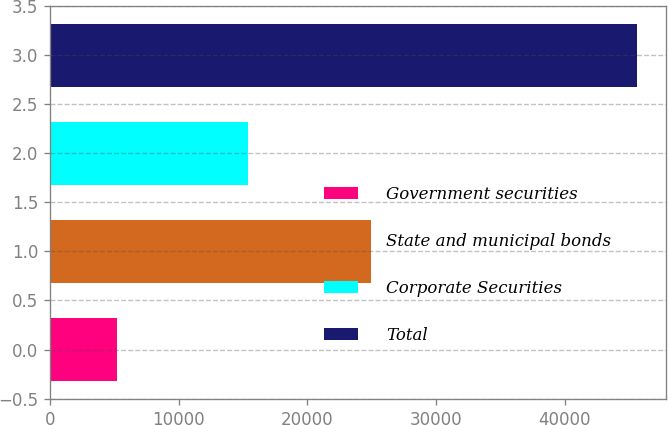Convert chart to OTSL. <chart><loc_0><loc_0><loc_500><loc_500><bar_chart><fcel>Government securities<fcel>State and municipal bonds<fcel>Corporate Securities<fcel>Total<nl><fcel>5179<fcel>24969<fcel>15429<fcel>45577<nl></chart> 